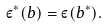Convert formula to latex. <formula><loc_0><loc_0><loc_500><loc_500>\varepsilon ^ { * } ( b ) = \varepsilon ( b ^ { * } ) .</formula> 